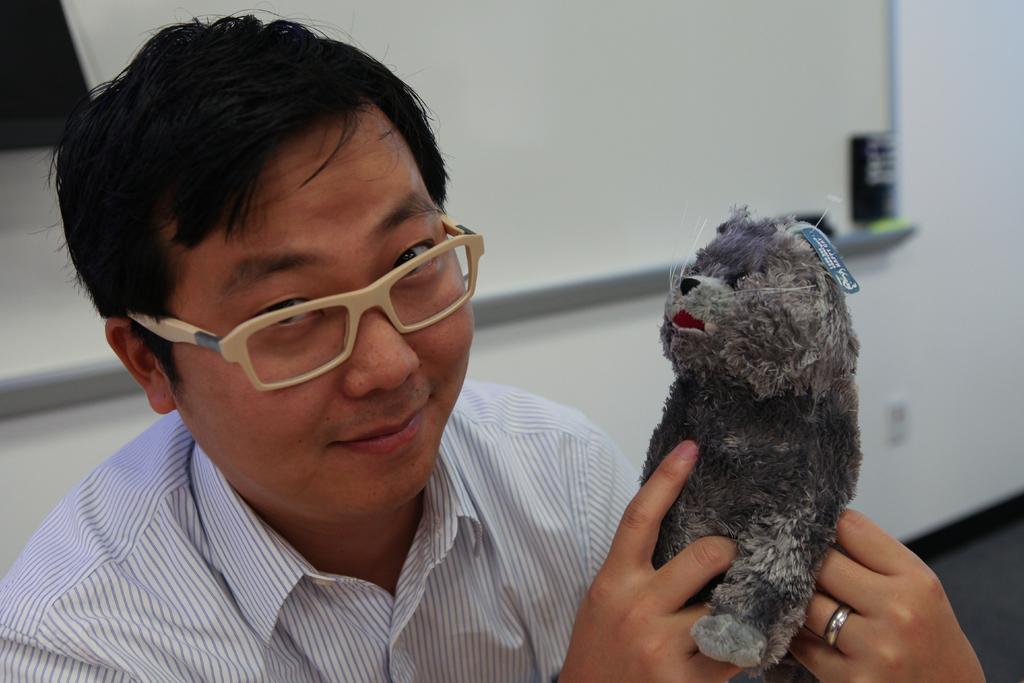Please provide a concise description of this image. On the background we can see a white board and a wall. This is a floor. Here we can see man wearing spectacles , holding a doll in his hands. 